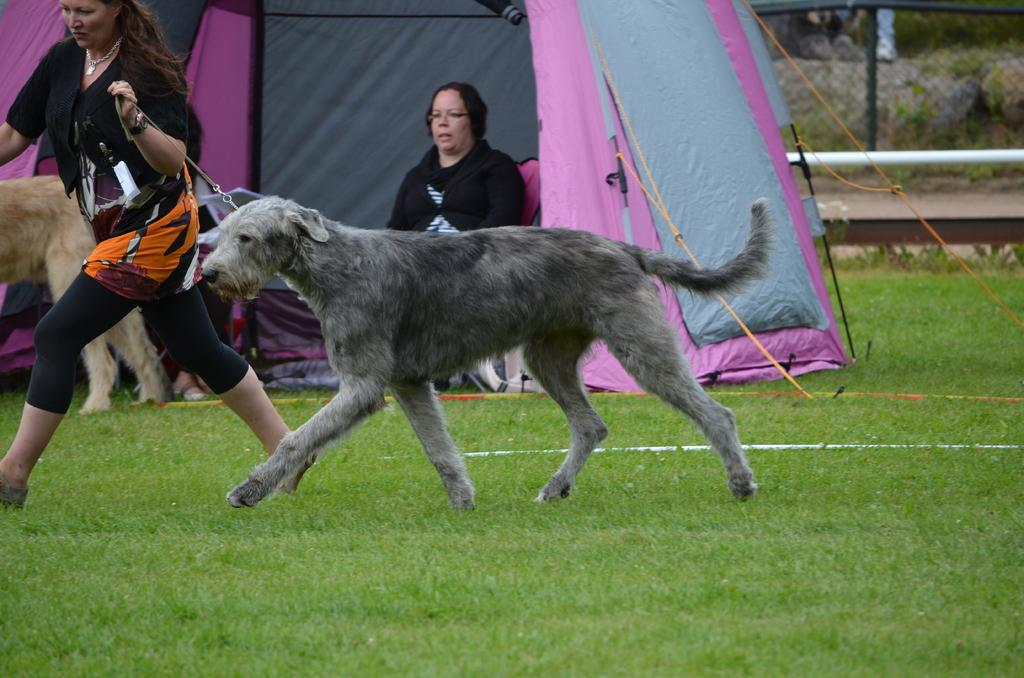What is the woman in the image doing? The woman is running in the image. Who is the woman running with? The woman is running with a dog. What type of surface are they running on? They are running on grass. Can you describe the background of the image? There is a woman sitting under a tent and a fence with rods and ropes in the background. What type of pollution can be seen in the image? There is no pollution visible in the image. What kind of apparatus is being used by the woman running? The woman running is not using any apparatus; she is simply running with her dog. 